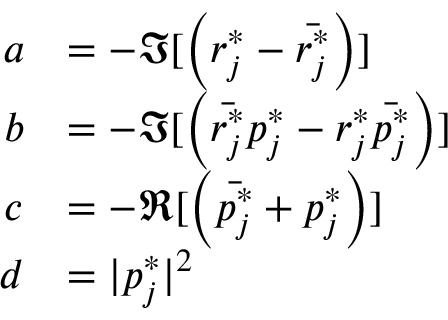<formula> <loc_0><loc_0><loc_500><loc_500>\begin{array} { r l } { a } & { = - \Im [ \left ( r _ { j } ^ { * } - \bar { r _ { j } ^ { * } } \right ) ] } \\ { b } & { = - \Im [ \left ( \bar { r _ { j } ^ { * } } p _ { j } ^ { * } - r _ { j } ^ { * } \bar { p _ { j } ^ { * } } \right ) ] } \\ { c } & { = - \Re [ \left ( \bar { p _ { j } ^ { * } } + p _ { j } ^ { * } \right ) ] } \\ { d } & { = | p _ { j } ^ { * } | ^ { 2 } } \end{array}</formula> 